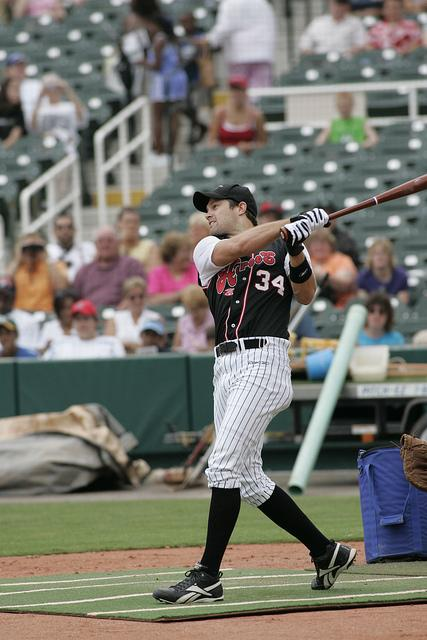Why is the player wearing gloves?

Choices:
A) warmth
B) grip
C) fashion
D) health grip 